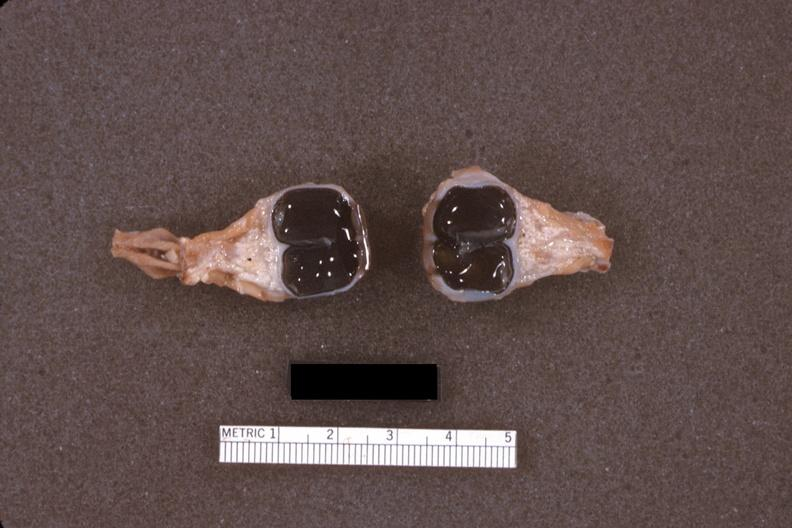what is present?
Answer the question using a single word or phrase. Conjoined twins cephalothoracopagus janiceps 